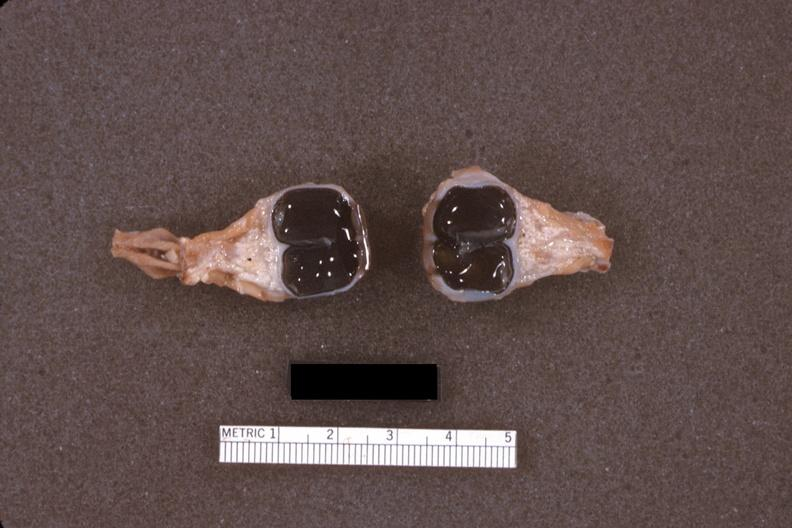what is present?
Answer the question using a single word or phrase. Conjoined twins cephalothoracopagus janiceps 